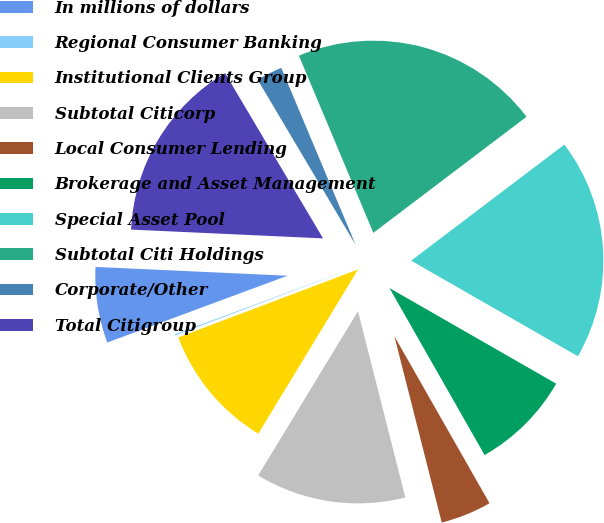Convert chart. <chart><loc_0><loc_0><loc_500><loc_500><pie_chart><fcel>In millions of dollars<fcel>Regional Consumer Banking<fcel>Institutional Clients Group<fcel>Subtotal Citicorp<fcel>Local Consumer Lending<fcel>Brokerage and Asset Management<fcel>Special Asset Pool<fcel>Subtotal Citi Holdings<fcel>Corporate/Other<fcel>Total Citigroup<nl><fcel>6.38%<fcel>0.1%<fcel>10.56%<fcel>12.65%<fcel>4.28%<fcel>8.47%<fcel>18.61%<fcel>21.01%<fcel>2.19%<fcel>15.75%<nl></chart> 